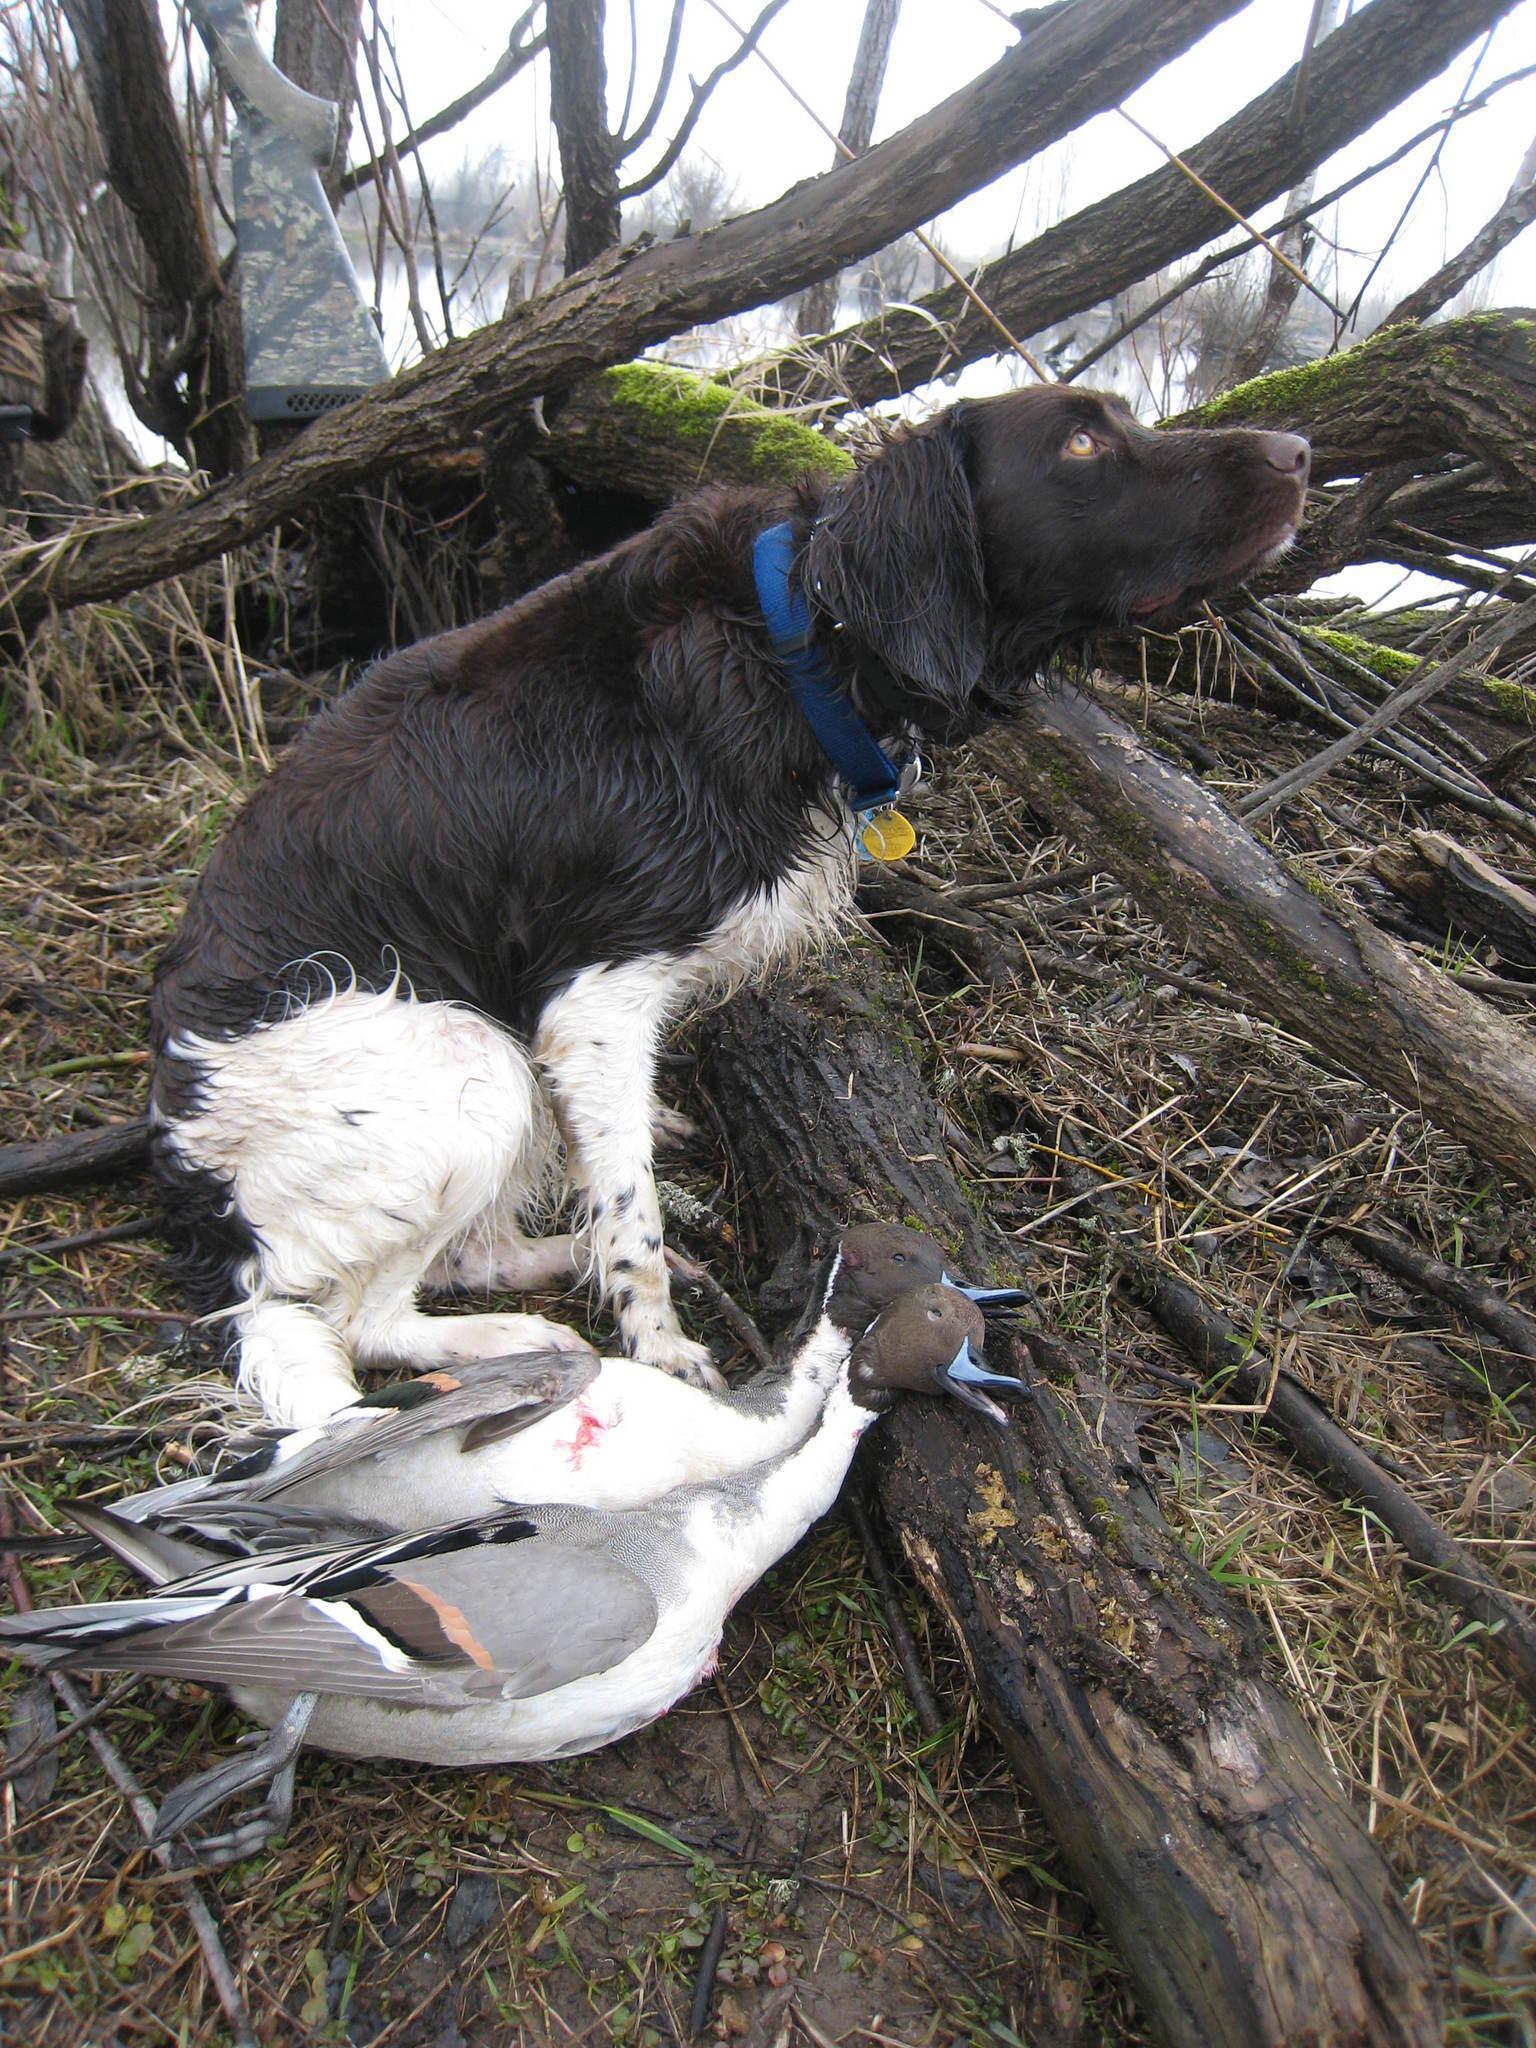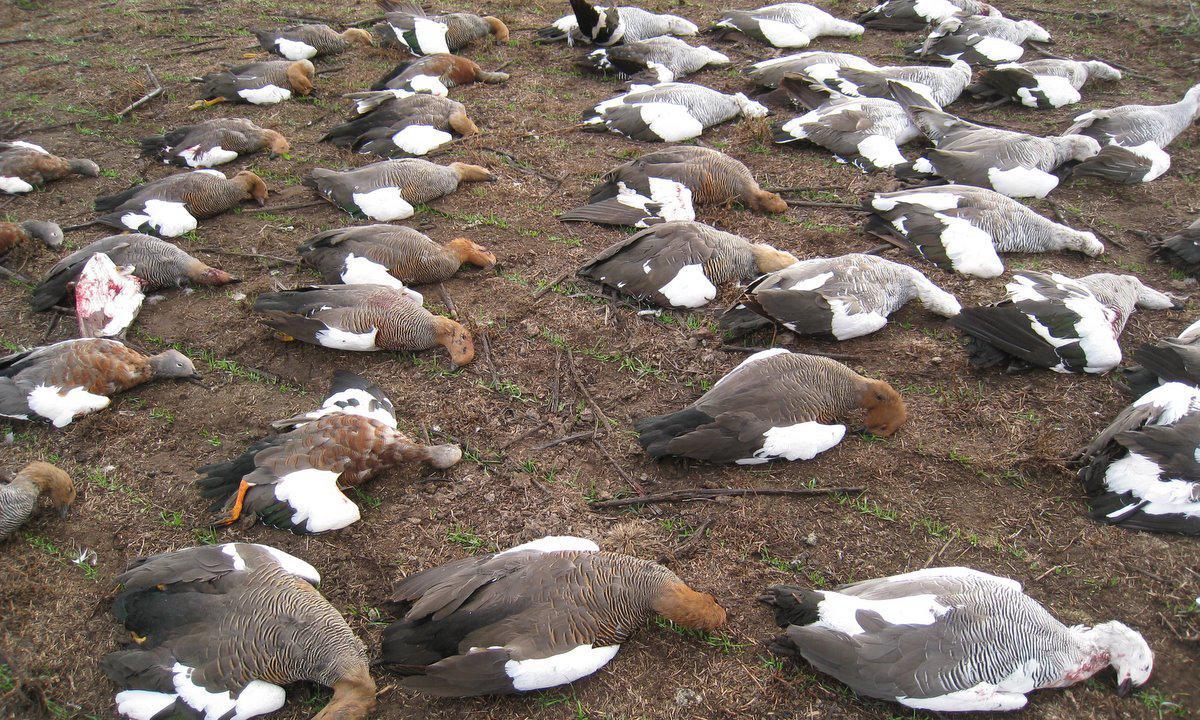The first image is the image on the left, the second image is the image on the right. Considering the images on both sides, is "An image includes at least one hunter, dog and many dead birds." valid? Answer yes or no. No. The first image is the image on the left, the second image is the image on the right. Considering the images on both sides, is "One of the photos contains one or more dogs." valid? Answer yes or no. Yes. 